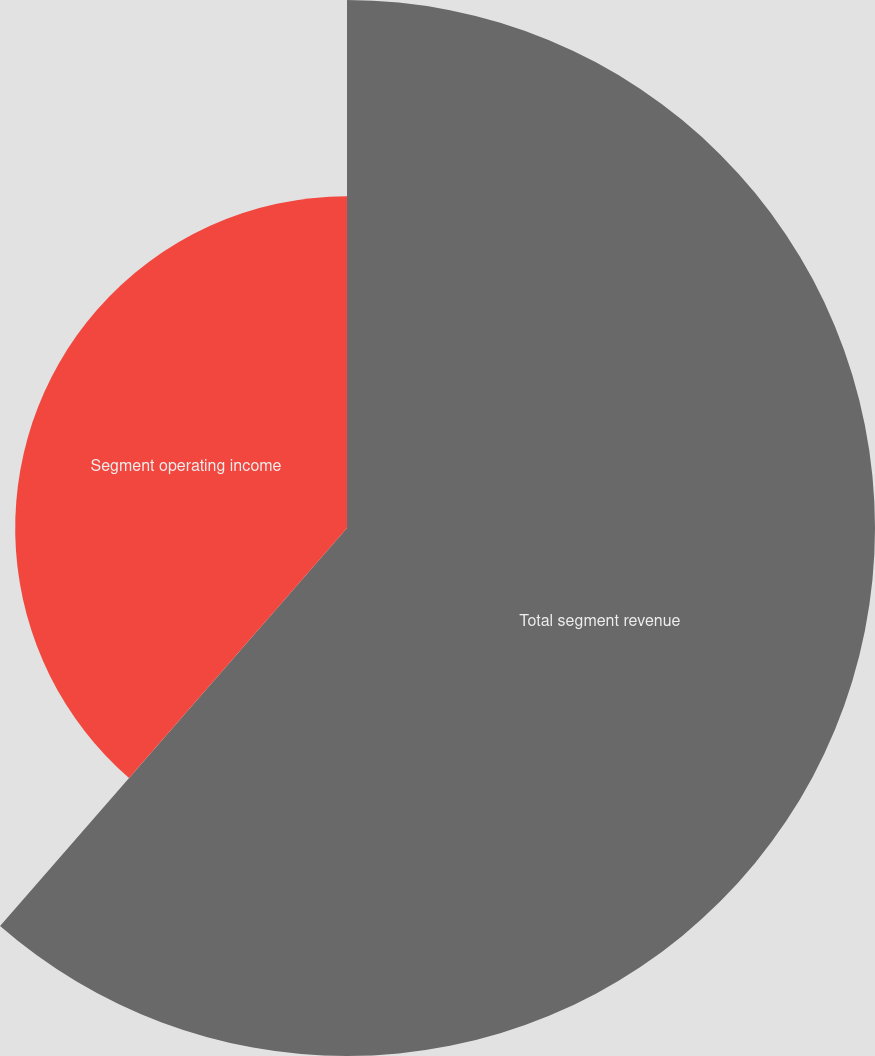Convert chart. <chart><loc_0><loc_0><loc_500><loc_500><pie_chart><fcel>Total segment revenue<fcel>Segment operating income<nl><fcel>61.41%<fcel>38.59%<nl></chart> 